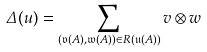<formula> <loc_0><loc_0><loc_500><loc_500>\Delta ( u ) = \sum _ { ( \mathfrak { v } ( A ) , \mathfrak { w } ( A ) ) \in R ( \mathfrak { u } ( A ) ) } v \otimes w</formula> 